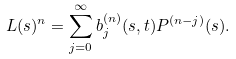<formula> <loc_0><loc_0><loc_500><loc_500>L ( s ) ^ { n } = \sum _ { j = 0 } ^ { \infty } b ^ { ( n ) } _ { j } ( s , t ) P ^ { ( n - j ) } ( s ) .</formula> 